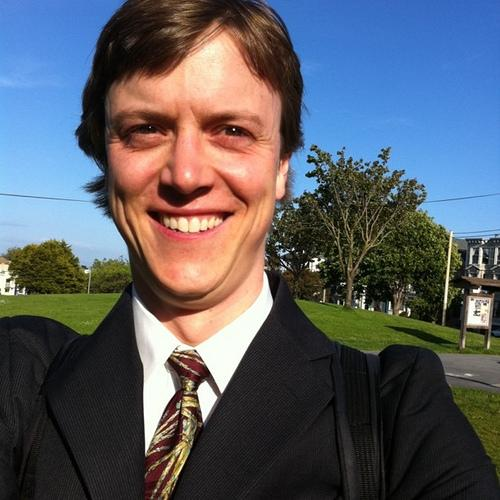What is the color and style of the person's hair? The person has straight medium brown hair parted on the left. How many different objects are described in the image? There are 40 different objects described in the image. Identify the main activity of the person in the image. The man is taking a selfie with a big smile. Describe the necktie worn by the person in the image in one sentence. The man is wearing a red and gold tie with a windsor knot. Mention a detail related to the person's eyes and something related to their clothing. The man's eyes have wrinkles around them, and he's wearing a black suit jacket. What type of dress shirt is the man in the image wearing? The man is wearing a white dress shirt. Summarize the key features of the person in the image in a single sentence. The man with straight medium brown hair, brown eyes, a very big smile, and wrinkles around his eyes is wearing a black suit jacket, white dress shirt, and a red and gold tie. List three key features of the background environment in the image. Tall deciduous trees, a power line, and an apartment building. As you notice a majestic bald eagle soaring through the sky, what wing span and plumage pattern can you identify? There is no mention of an eagle or any birds in the list of objects within the image. This instruction is misleading by creating a sense of awe and expansiveness that is not present in the objects, as well as using an interrogative sentence to elicit curiosity. Observe a curious extraterrestrial spacecraft hovering above the apartment building with glowing lights surrounding its edges. What does this reveal about its purpose? There is no mention of any spacecraft or extraterrestrial presence in the list of objects within the image. This instruction creates an air of intrigue and mystery, using an interrogative sentence to provoke thought about something that does not exist in the image. Locate the luxurious sports car parked on the side of the road with a shiny silver exterior and a prominent spoiler. There is no mention of any cars, especially not a sports car, in the list of objects present in the image. This instruction misleads the reader by suggesting a luxurious and flashy item that is completely unrelated to the objects in the image. Can you identify the playful kitten located near the trees? It's wearing a small red collar with a bell attached to it. No, it's not mentioned in the image. West of a sign post, you will see a fascinating waterfall cascading in the distance. Can you estimate the height of this natural wonder? There is no mention of a waterfall in the provided list of objects in the image. This instruction misleads readers with a captivating and appealing natural event, asking for estimations that cannot be made based on the available information. 